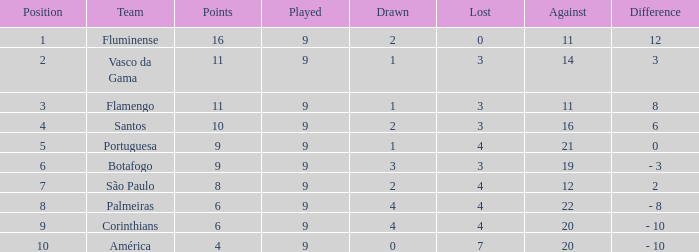Which position features a player with a number greater than 9? None. 